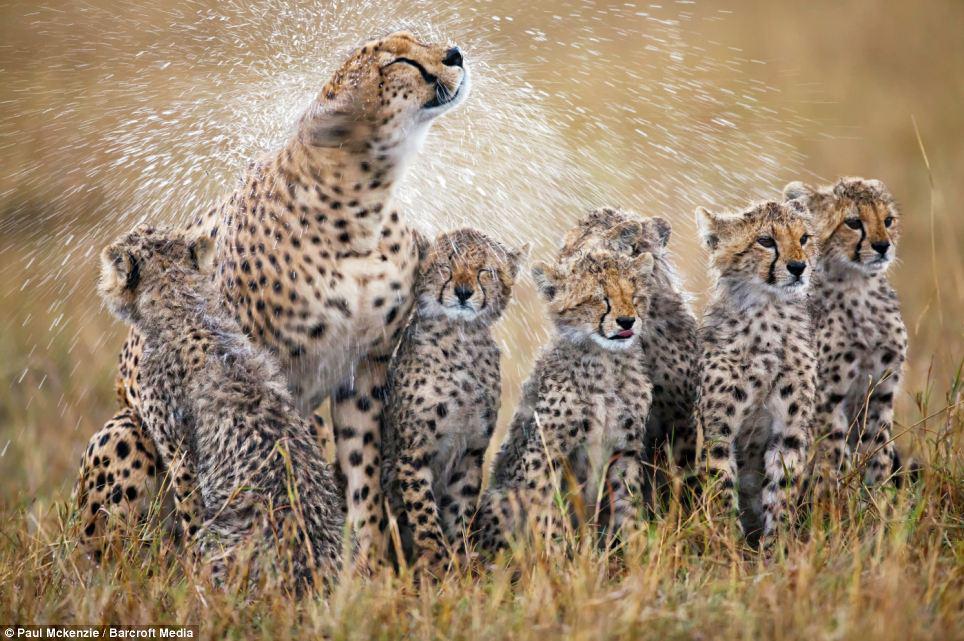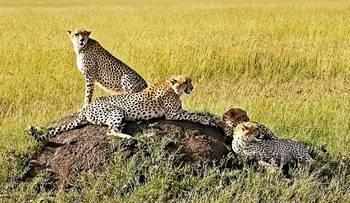The first image is the image on the left, the second image is the image on the right. Considering the images on both sides, is "The image on the right has one lone cheetah sitting in the grass." valid? Answer yes or no. No. The first image is the image on the left, the second image is the image on the right. Considering the images on both sides, is "One image features baby cheetahs next to an adult cheetah" valid? Answer yes or no. Yes. 